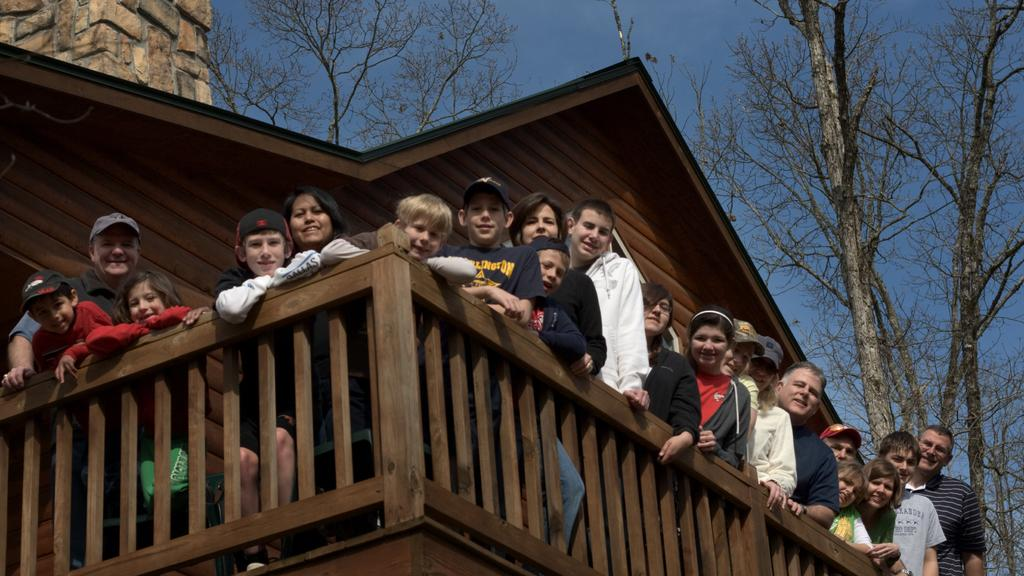Who or what can be seen in the image? There are people in the image. What is present near the people? There is a railing in the image. What type of wall is visible in the image? There is a wooden wall in the image. What can be seen in the background of the image? Trees, a rock wall, and the sky are visible in the background of the image. Can you see the ocean in the image? No, the ocean is not present in the image. 